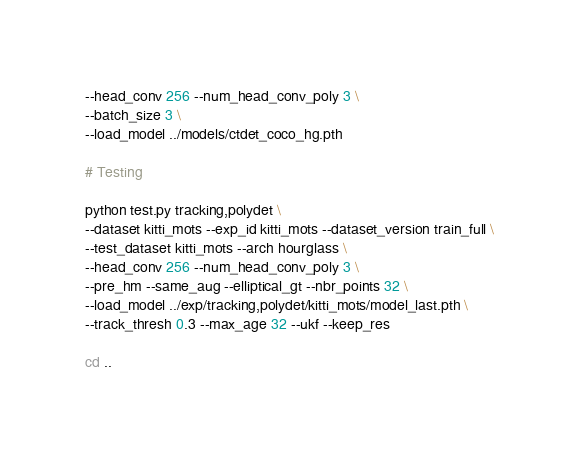<code> <loc_0><loc_0><loc_500><loc_500><_Bash_>--head_conv 256 --num_head_conv_poly 3 \
--batch_size 3 \
--load_model ../models/ctdet_coco_hg.pth

# Testing

python test.py tracking,polydet \
--dataset kitti_mots --exp_id kitti_mots --dataset_version train_full \
--test_dataset kitti_mots --arch hourglass \
--head_conv 256 --num_head_conv_poly 3 \
--pre_hm --same_aug --elliptical_gt --nbr_points 32 \
--load_model ../exp/tracking,polydet/kitti_mots/model_last.pth \
--track_thresh 0.3 --max_age 32 --ukf --keep_res

cd ..</code> 